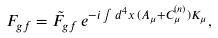Convert formula to latex. <formula><loc_0><loc_0><loc_500><loc_500>F _ { g f } = \tilde { F } _ { g f } \, e ^ { - i \int d ^ { 4 } x \, ( A _ { \mu } + C ^ { ( n ) } _ { \mu } ) K _ { \mu } } ,</formula> 